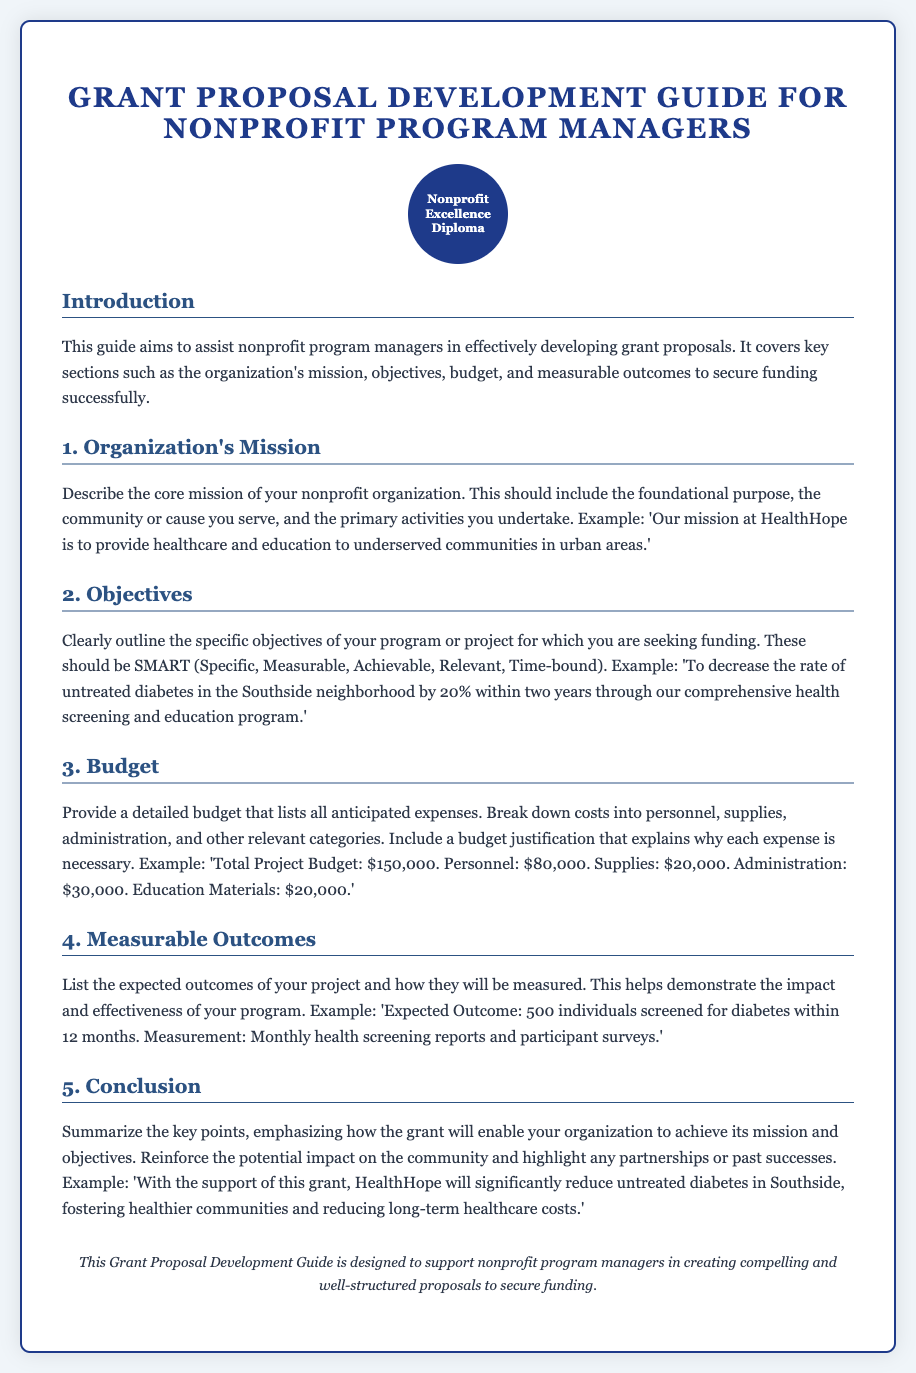What is the title of the guide? The title of the guide is presented prominently at the top of the document.
Answer: Grant Proposal Development Guide for Nonprofit Program Managers What is the purpose of the guide? The document states the aim of the guide in the introduction section.
Answer: To assist nonprofit program managers in effectively developing grant proposals What does SMART stand for in the objectives section? SMART is an acronym describing the qualities the objectives should possess.
Answer: Specific, Measurable, Achievable, Relevant, Time-bound What is the total project budget mentioned? The total project budget is detailed in the budget section of the document.
Answer: $150,000 What is one example of a measurable outcome provided? The document lists expected outcomes along with their measurement methods.
Answer: 500 individuals screened for diabetes within 12 months What is the key to describing the organization's mission? The guide specifies that the mission should communicate the foundational purpose and community served.
Answer: Foundational purpose, community or cause served How many main sections does the guide contain? The main sections of the guide are numbered in the document for clarity.
Answer: Five What is included in the budget justification? The document suggests that a budget justification explains the necessity of each expense.
Answer: Why each expense is necessary What is the background color of the document? The background color is indicated in the style section of the HTML code.
Answer: #f0f5f9 